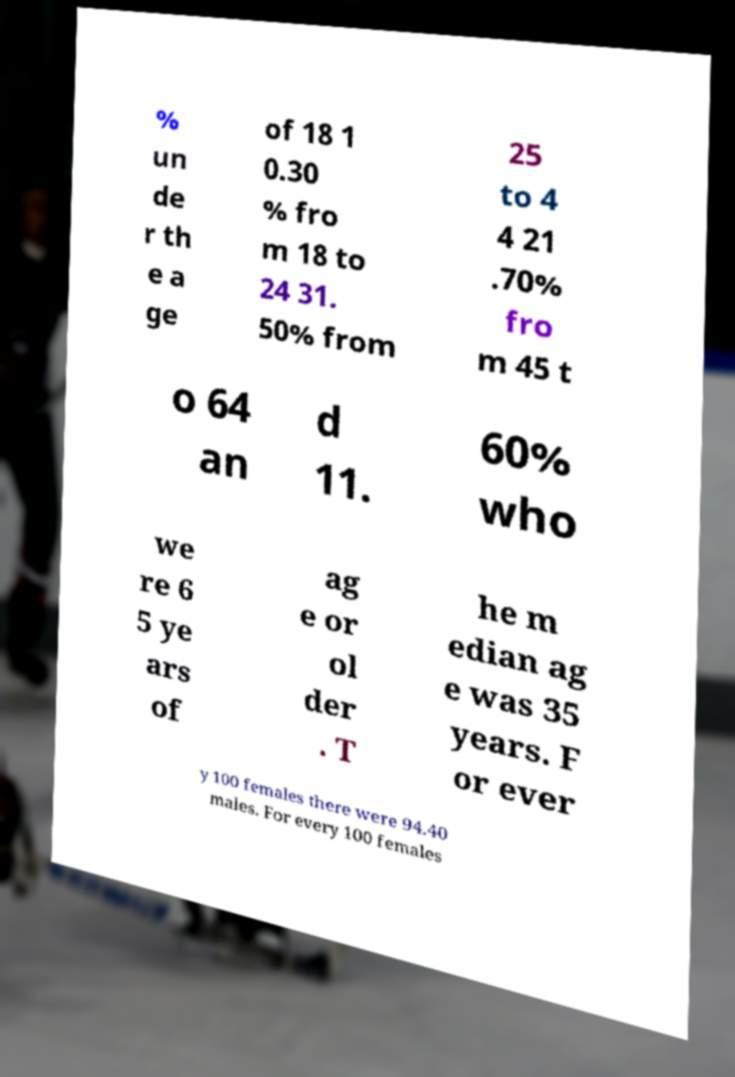I need the written content from this picture converted into text. Can you do that? % un de r th e a ge of 18 1 0.30 % fro m 18 to 24 31. 50% from 25 to 4 4 21 .70% fro m 45 t o 64 an d 11. 60% who we re 6 5 ye ars of ag e or ol der . T he m edian ag e was 35 years. F or ever y 100 females there were 94.40 males. For every 100 females 